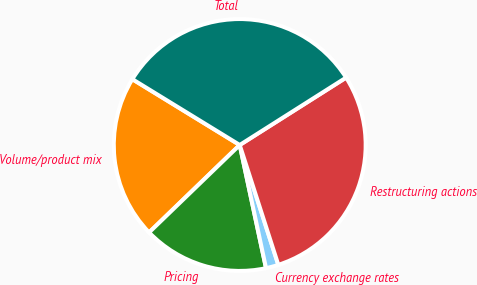<chart> <loc_0><loc_0><loc_500><loc_500><pie_chart><fcel>Volume/product mix<fcel>Pricing<fcel>Currency exchange rates<fcel>Restructuring actions<fcel>Total<nl><fcel>20.97%<fcel>16.13%<fcel>1.61%<fcel>29.03%<fcel>32.26%<nl></chart> 